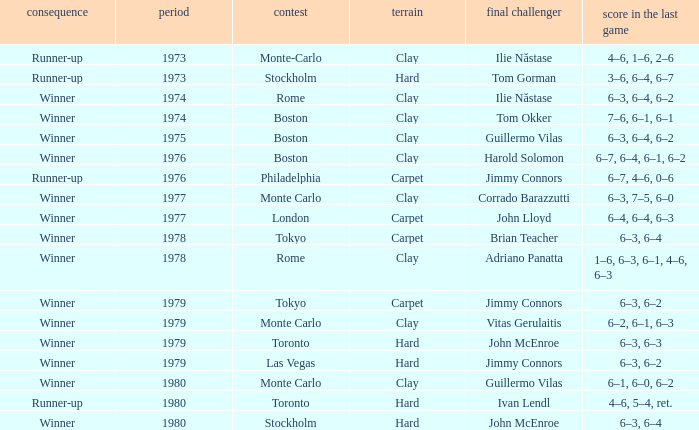Name the number of year for 6–3, 6–2 hard surface 1.0. 